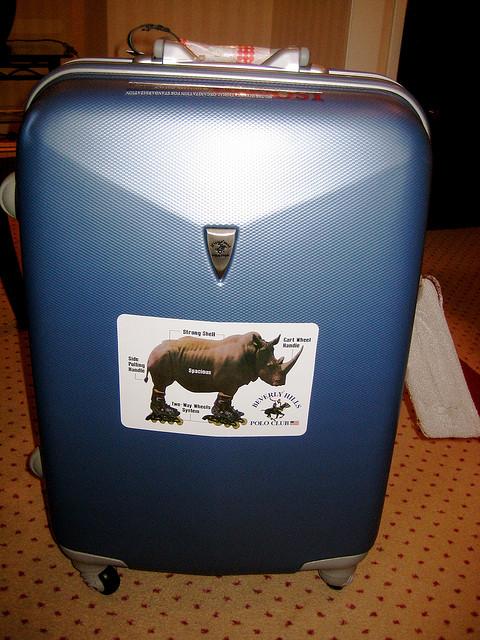Is this something you would see at an airport?
Quick response, please. Yes. What type of animal is on the picture here?
Short answer required. Rhino. What is the blue object?
Be succinct. Suitcase. 